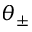<formula> <loc_0><loc_0><loc_500><loc_500>\theta _ { \pm }</formula> 